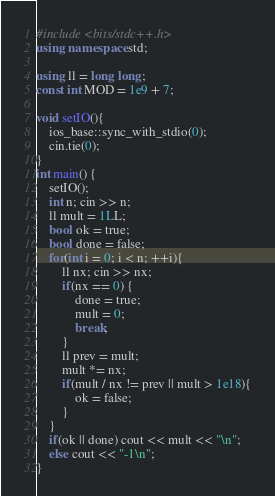Convert code to text. <code><loc_0><loc_0><loc_500><loc_500><_C++_>#include <bits/stdc++.h>
using namespace std;

using ll = long long;
const int MOD = 1e9 + 7;

void setIO(){
	ios_base::sync_with_stdio(0);
	cin.tie(0);
}
int main() {
	setIO();
	int n; cin >> n;
	ll mult = 1LL;
	bool ok = true;
	bool done = false;
	for(int i = 0; i < n; ++i){
		ll nx; cin >> nx;
		if(nx == 0) {
			done = true;
			mult = 0;
			break;
		}
		ll prev = mult;
		mult *= nx;
		if(mult / nx != prev || mult > 1e18){
			ok = false;
		}
	}
	if(ok || done) cout << mult << "\n";
	else cout << "-1\n";
}
</code> 